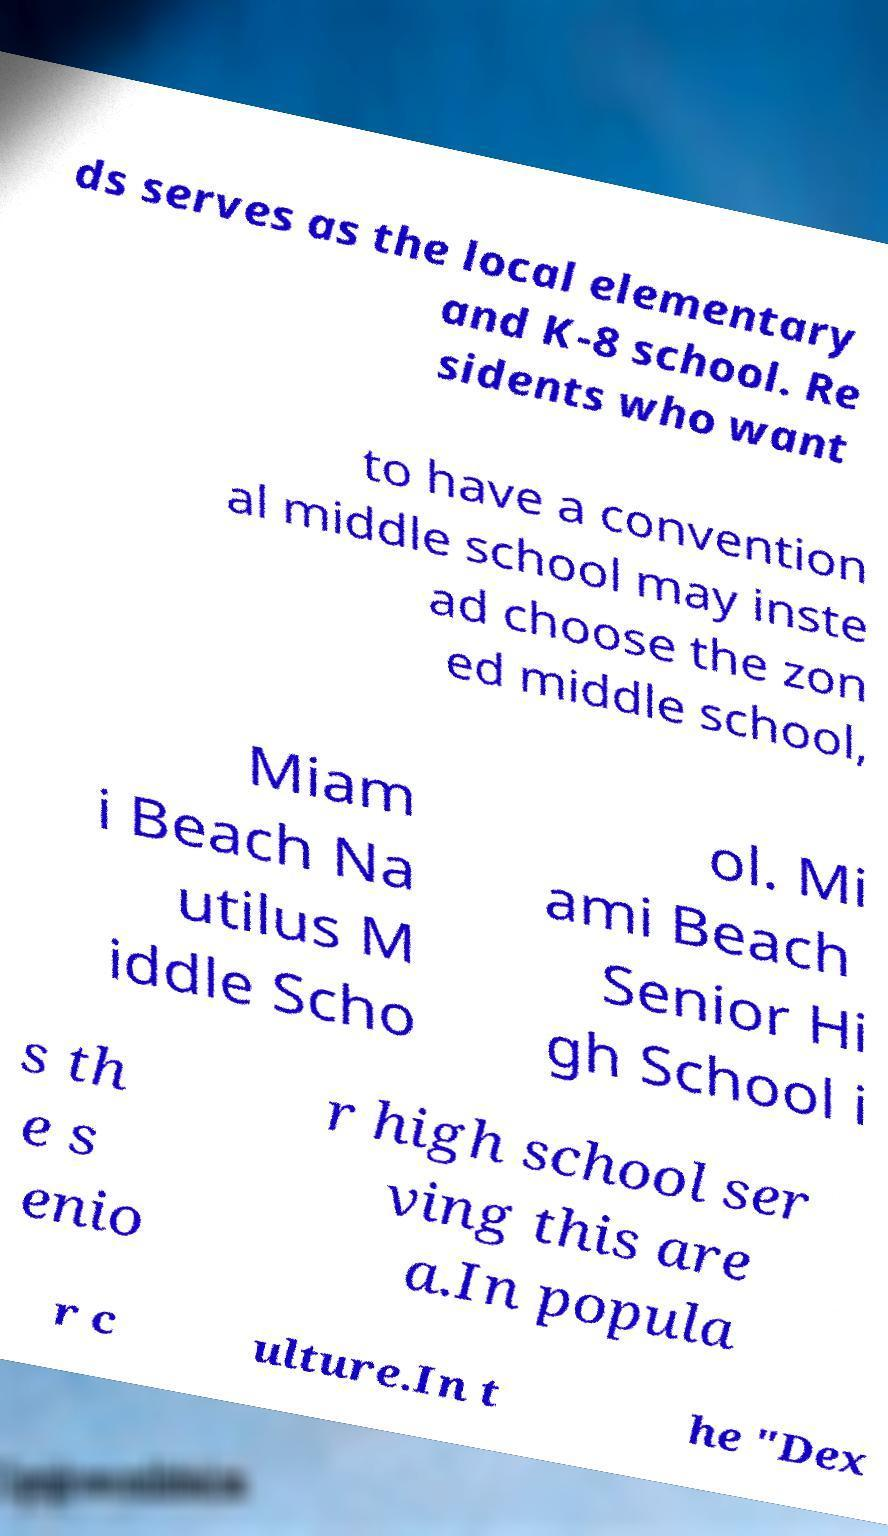Can you read and provide the text displayed in the image?This photo seems to have some interesting text. Can you extract and type it out for me? ds serves as the local elementary and K-8 school. Re sidents who want to have a convention al middle school may inste ad choose the zon ed middle school, Miam i Beach Na utilus M iddle Scho ol. Mi ami Beach Senior Hi gh School i s th e s enio r high school ser ving this are a.In popula r c ulture.In t he "Dex 